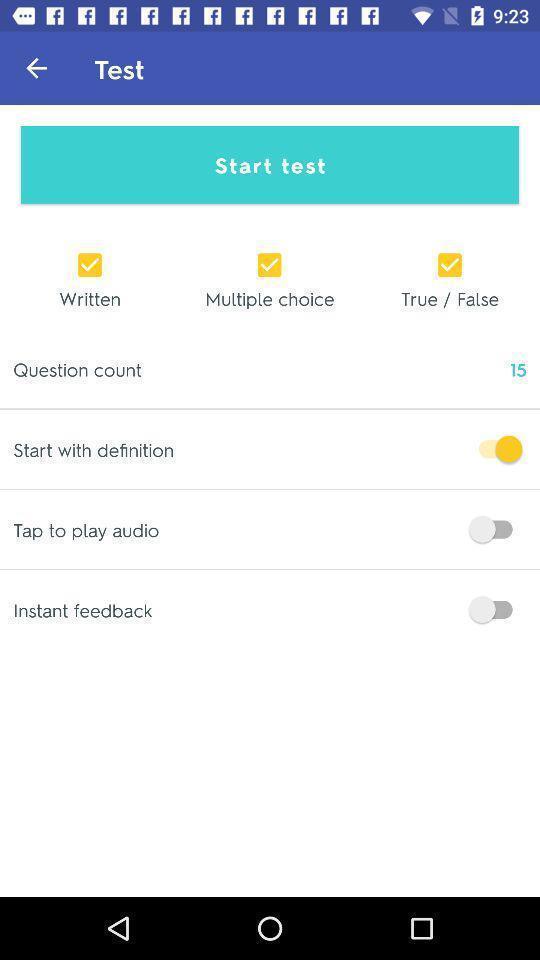Give me a narrative description of this picture. Screen showing start test in an learning application. 